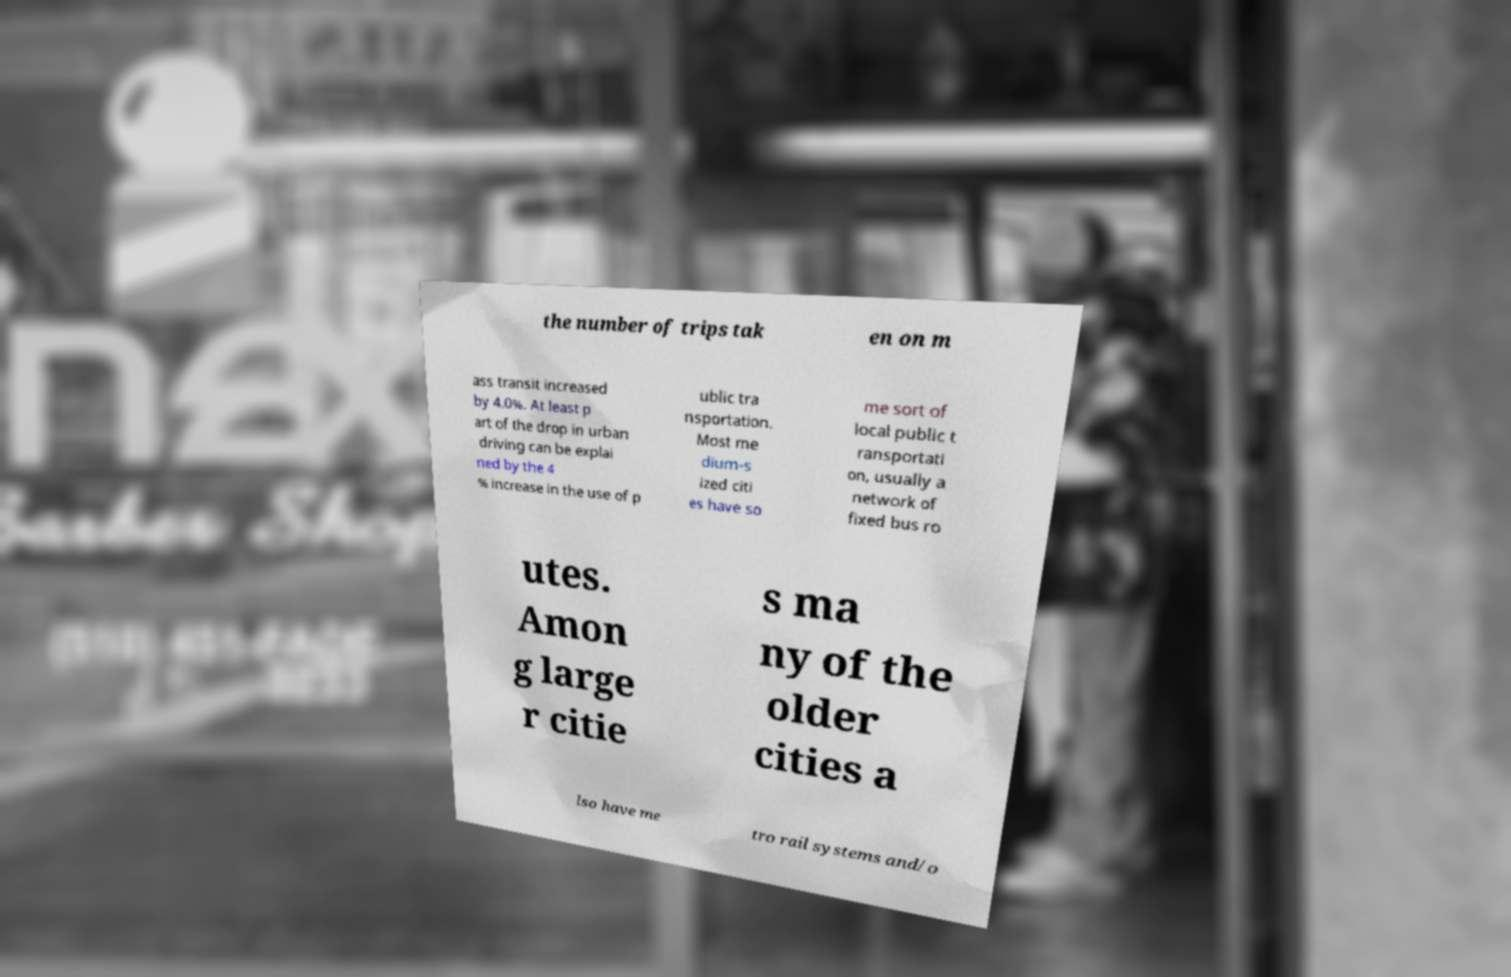There's text embedded in this image that I need extracted. Can you transcribe it verbatim? the number of trips tak en on m ass transit increased by 4.0%. At least p art of the drop in urban driving can be explai ned by the 4 % increase in the use of p ublic tra nsportation. Most me dium-s ized citi es have so me sort of local public t ransportati on, usually a network of fixed bus ro utes. Amon g large r citie s ma ny of the older cities a lso have me tro rail systems and/o 